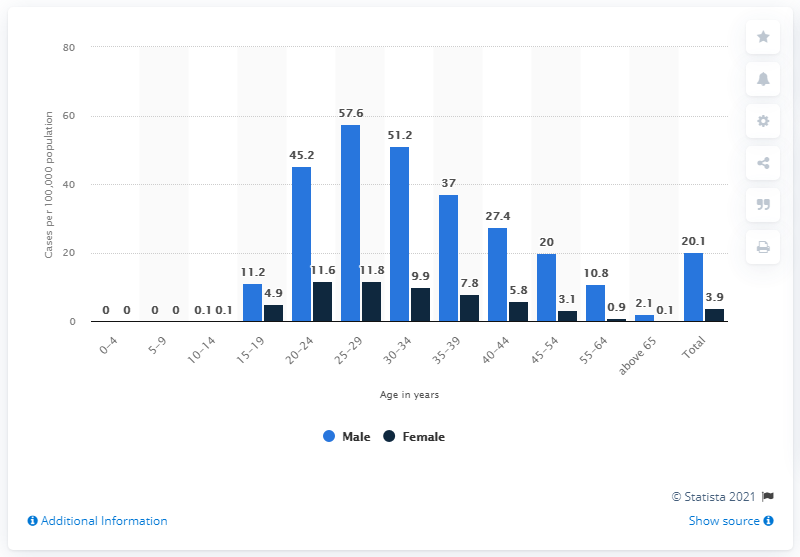Highlight a few significant elements in this photo. The reported number of cases of syphilis per 100,000 people between the ages of 25 and 29 was 57.6. 